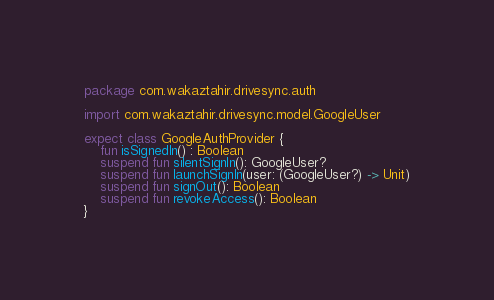<code> <loc_0><loc_0><loc_500><loc_500><_Kotlin_>package com.wakaztahir.drivesync.auth

import com.wakaztahir.drivesync.model.GoogleUser

expect class GoogleAuthProvider {
    fun isSignedIn() : Boolean
    suspend fun silentSignIn(): GoogleUser?
    suspend fun launchSignIn(user: (GoogleUser?) -> Unit)
    suspend fun signOut(): Boolean
    suspend fun revokeAccess(): Boolean
}</code> 